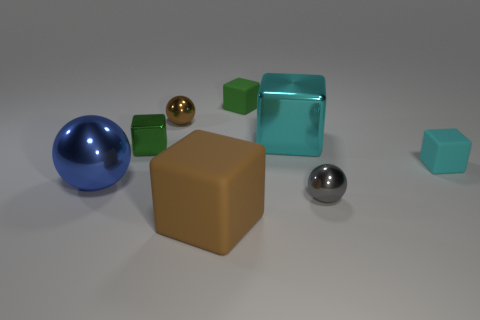Subtract all blue balls. How many balls are left? 2 Subtract all purple balls. How many cyan cubes are left? 2 Subtract 1 cubes. How many cubes are left? 4 Subtract all cyan cubes. How many cubes are left? 3 Subtract all yellow spheres. Subtract all red cylinders. How many spheres are left? 3 Add 1 big brown blocks. How many objects exist? 9 Subtract all spheres. How many objects are left? 5 Subtract 0 gray cylinders. How many objects are left? 8 Subtract all purple cubes. Subtract all blue shiny objects. How many objects are left? 7 Add 4 green cubes. How many green cubes are left? 6 